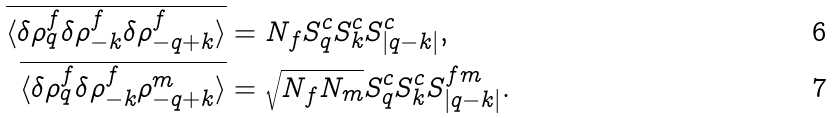Convert formula to latex. <formula><loc_0><loc_0><loc_500><loc_500>\overline { \langle \delta \rho ^ { f } _ { q } \delta \rho ^ { f } _ { - k } \delta \rho ^ { f } _ { - q + k } \rangle } & = N _ { f } S ^ { c } _ { q } S ^ { c } _ { k } S ^ { c } _ { | q - k | } , \\ \overline { \langle \delta \rho ^ { f } _ { q } \delta \rho ^ { f } _ { - k } \rho ^ { m } _ { - q + k } \rangle } & = \sqrt { N _ { f } N _ { m } } S ^ { c } _ { q } S ^ { c } _ { k } S ^ { f m } _ { | q - k | } .</formula> 